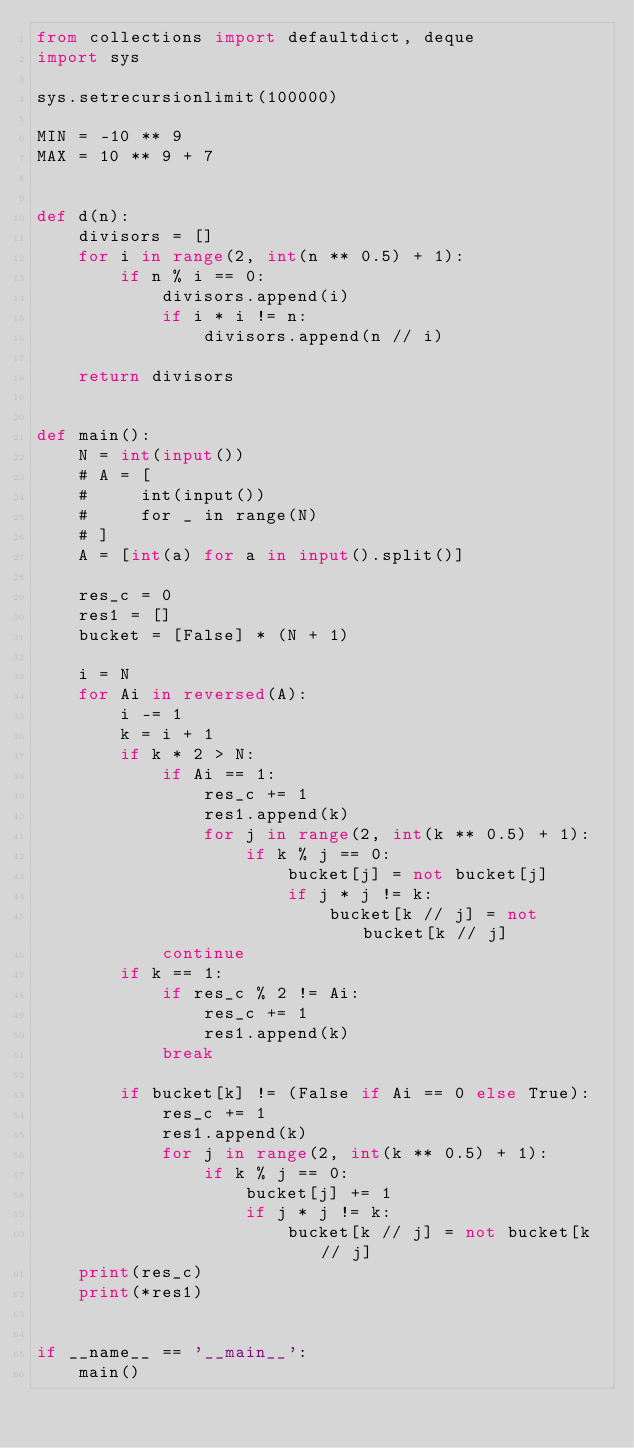Convert code to text. <code><loc_0><loc_0><loc_500><loc_500><_Python_>from collections import defaultdict, deque
import sys

sys.setrecursionlimit(100000)

MIN = -10 ** 9
MAX = 10 ** 9 + 7


def d(n):
    divisors = []
    for i in range(2, int(n ** 0.5) + 1):
        if n % i == 0:
            divisors.append(i)
            if i * i != n:
                divisors.append(n // i)

    return divisors


def main():
    N = int(input())
    # A = [
    #     int(input())
    #     for _ in range(N)
    # ]
    A = [int(a) for a in input().split()]

    res_c = 0
    res1 = []
    bucket = [False] * (N + 1)

    i = N
    for Ai in reversed(A):
        i -= 1
        k = i + 1
        if k * 2 > N:
            if Ai == 1:
                res_c += 1
                res1.append(k)
                for j in range(2, int(k ** 0.5) + 1):
                    if k % j == 0:
                        bucket[j] = not bucket[j]
                        if j * j != k:
                            bucket[k // j] = not bucket[k // j]
            continue
        if k == 1:
            if res_c % 2 != Ai:
                res_c += 1
                res1.append(k)
            break

        if bucket[k] != (False if Ai == 0 else True):
            res_c += 1
            res1.append(k)
            for j in range(2, int(k ** 0.5) + 1):
                if k % j == 0:
                    bucket[j] += 1
                    if j * j != k:
                        bucket[k // j] = not bucket[k // j]
    print(res_c)
    print(*res1)


if __name__ == '__main__':
    main()
</code> 